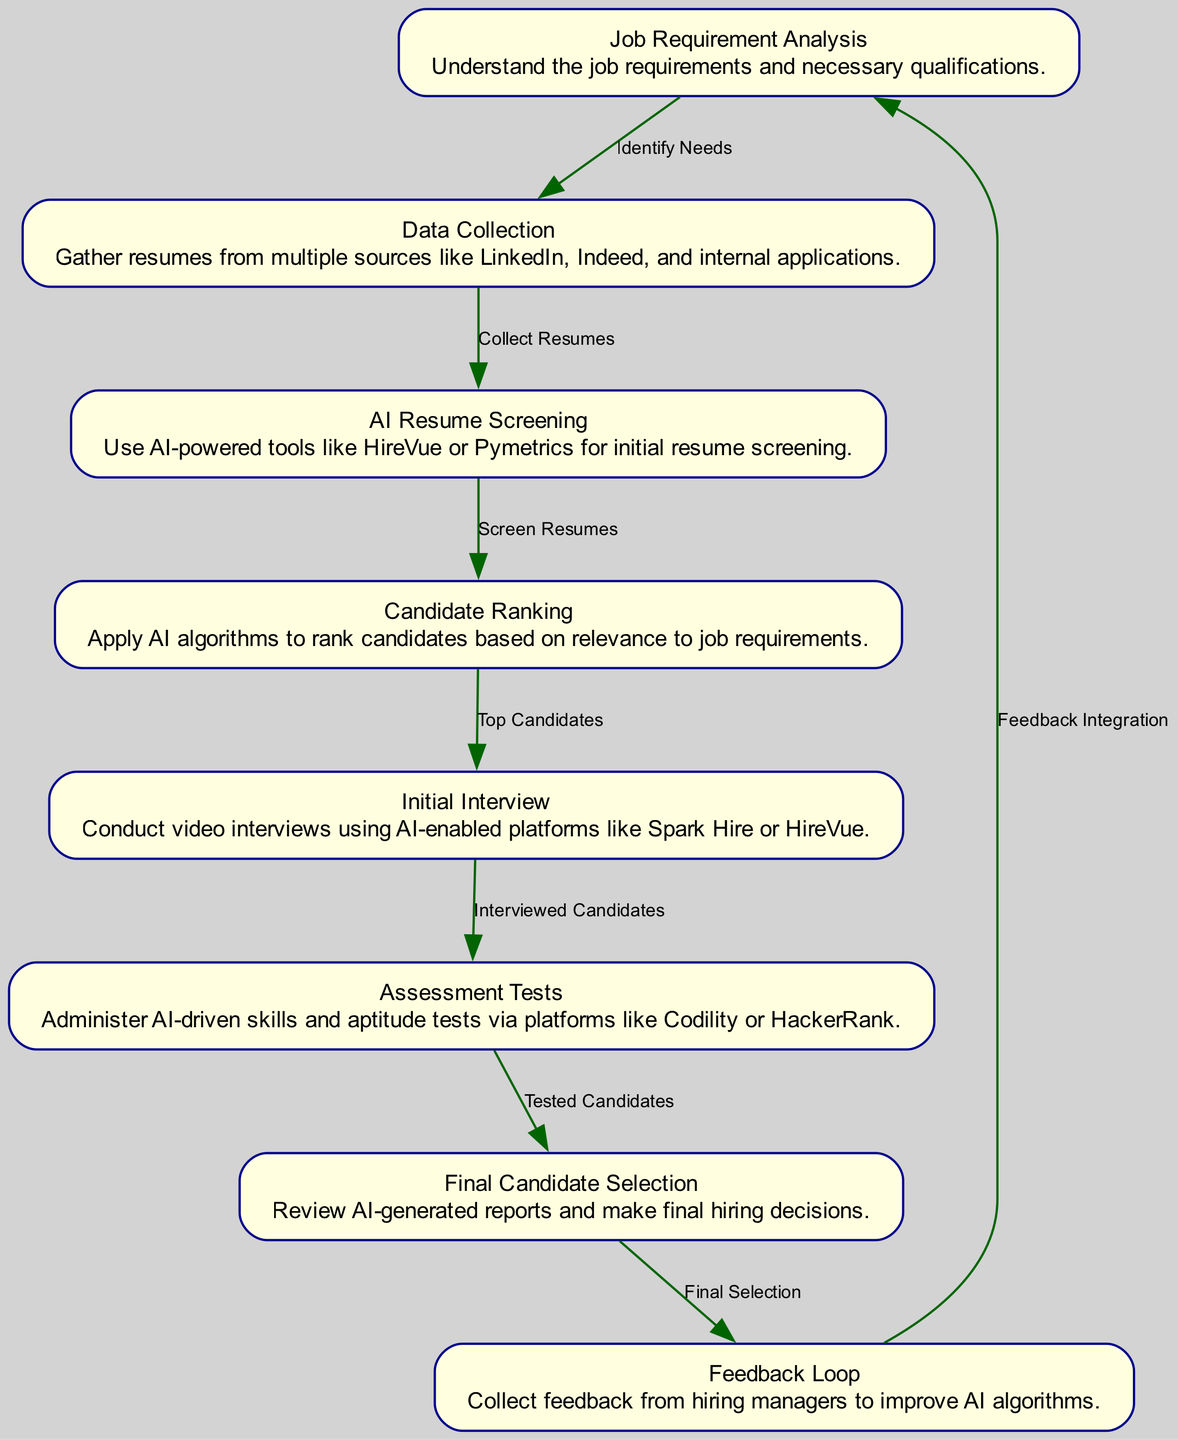What is the first step in the AI hiring workflow? The first node in the diagram is "Job Requirement Analysis," indicating it is the initial stage of the process.
Answer: Job Requirement Analysis How many nodes are in the diagram? By counting the items listed in the "nodes" section of the data, there are eight nodes representing different steps in the workflow.
Answer: 8 What does the edge between nodes 5 and 6 represent? The edge from "Initial Interview" to "Assessment Tests" is labeled "Interviewed Candidates," showing the relationship of candidates who have completed interviews moving to the assessment stage.
Answer: Interviewed Candidates Which AI tools are mentioned for initial resume screening? The description in node 3 states that tools like "HireVue" and "Pymetrics" are utilized for initial screening of resumes.
Answer: HireVue, Pymetrics What feedback mechanism is mentioned at the end of the workflow? Node 8 highlights a "Feedback Loop," which emphasizes the importance of collecting feedback from hiring managers to refine the AI algorithms used in the hiring process.
Answer: Feedback Loop How does the workflow cycle back into the initial analysis? The edge from node 8 ("Feedback Loop") to node 1 ("Job Requirement Analysis") indicates that feedback is integrated back into the initial job analysis phase to improve future hiring processes.
Answer: Feedback Integration What step follows after "Candidate Ranking"? According to the directed edges in the diagram, the step that follows "Candidate Ranking" (node 4) is "Initial Interview" (node 5).
Answer: Initial Interview Which platforms are used for conducting video interviews? The description for node 5 specifies that "AI-enabled platforms" such as "Spark Hire" and "HireVue" are used for video interviews.
Answer: Spark Hire, HireVue 